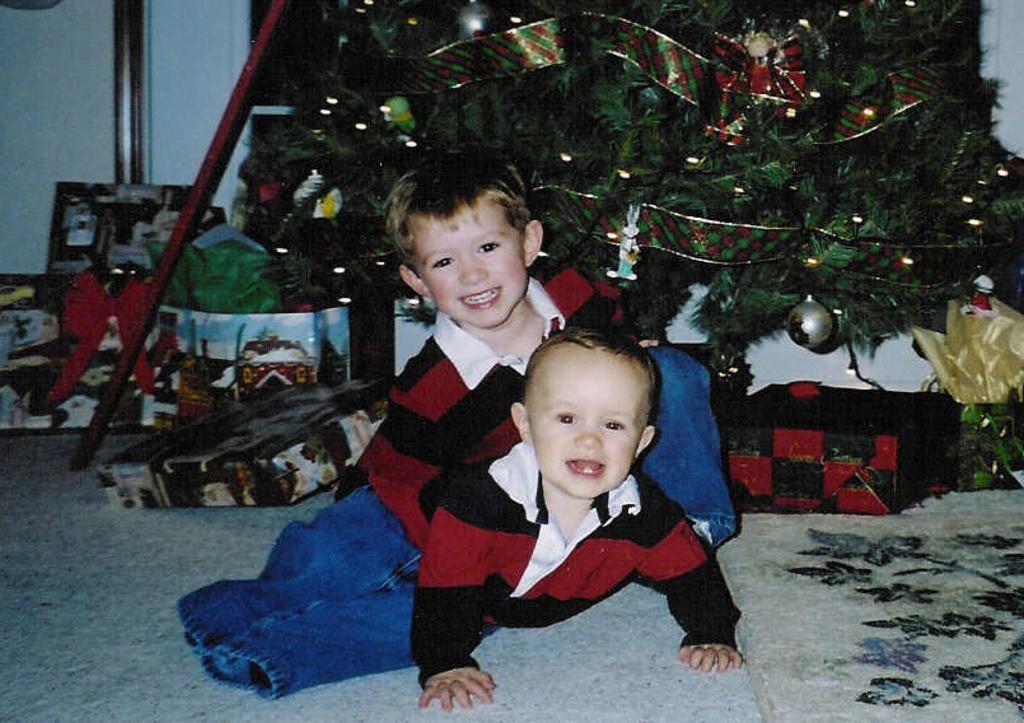How would you summarize this image in a sentence or two? In this picture there are two persons sitting and smiling. At the back there is a Christmas tree and there are objects on the tree and at the back there are gift boxes and bag. At the bottom there is a mat. 